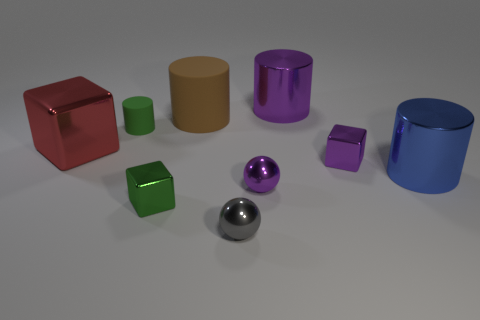Add 1 small green metal blocks. How many objects exist? 10 Subtract all blocks. How many objects are left? 6 Add 9 yellow rubber objects. How many yellow rubber objects exist? 9 Subtract 1 green cylinders. How many objects are left? 8 Subtract all blue cylinders. Subtract all large red things. How many objects are left? 7 Add 2 green metal objects. How many green metal objects are left? 3 